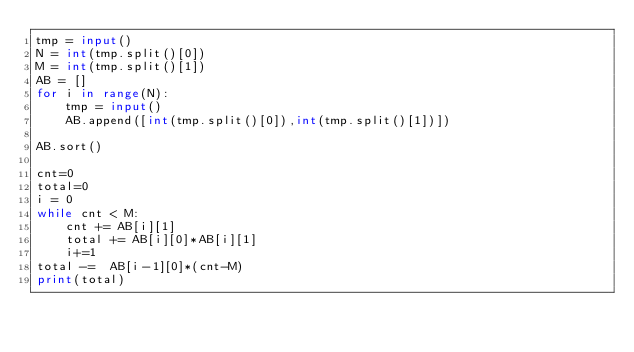Convert code to text. <code><loc_0><loc_0><loc_500><loc_500><_Python_>tmp = input()
N = int(tmp.split()[0])
M = int(tmp.split()[1])
AB = []
for i in range(N):
	tmp = input()
	AB.append([int(tmp.split()[0]),int(tmp.split()[1])])

AB.sort()

cnt=0
total=0
i = 0
while cnt < M:
	cnt += AB[i][1]
	total += AB[i][0]*AB[i][1]
	i+=1
total -=  AB[i-1][0]*(cnt-M)
print(total)</code> 